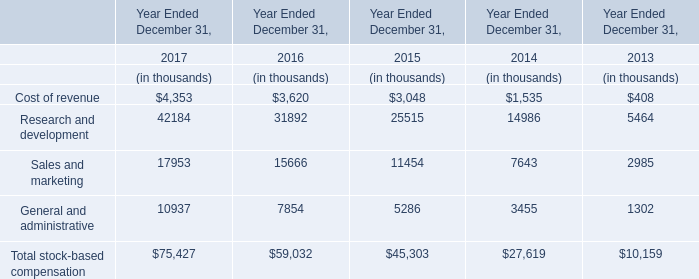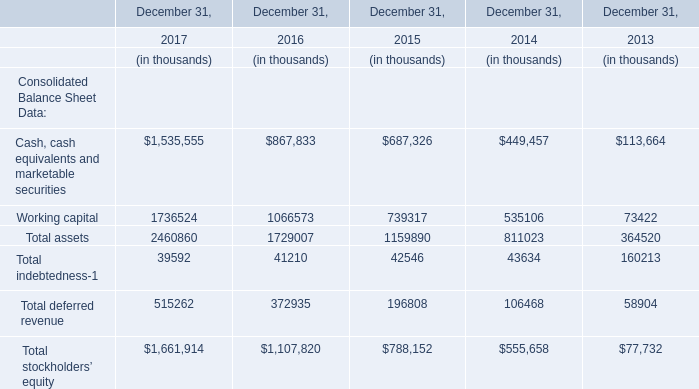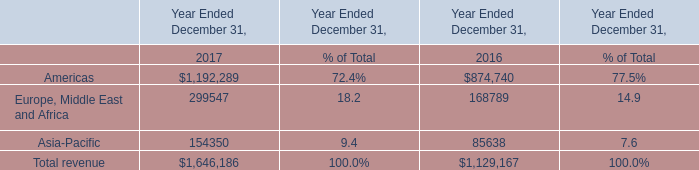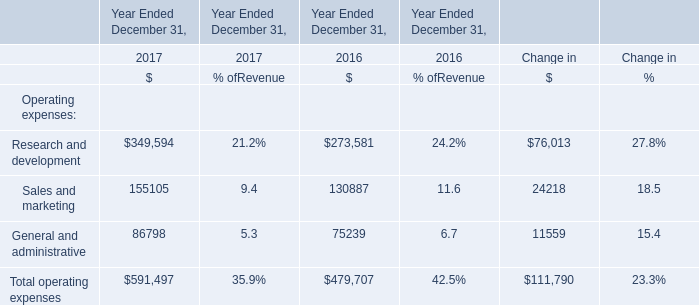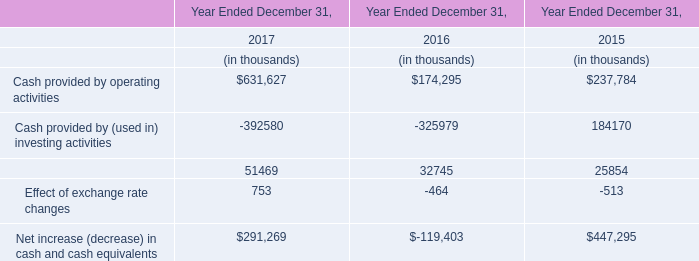What's the total amount of Total assets, Total indebtedness, Total deferred revenue and Total stockholders' equity in 2017? (in thousand) 
Computations: (((2460860 + 39592) + 515262) + 1661914)
Answer: 4677628.0. 